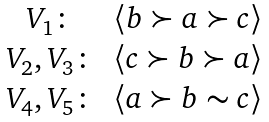Convert formula to latex. <formula><loc_0><loc_0><loc_500><loc_500>\begin{matrix} V _ { 1 } \colon & \left \langle b \succ a \succ c \right \rangle \\ V _ { 2 } , V _ { 3 } \colon & \left \langle c \succ b \succ a \right \rangle \\ V _ { 4 } , V _ { 5 } \colon & \left \langle a \succ b \sim c \right \rangle \\ \end{matrix}</formula> 